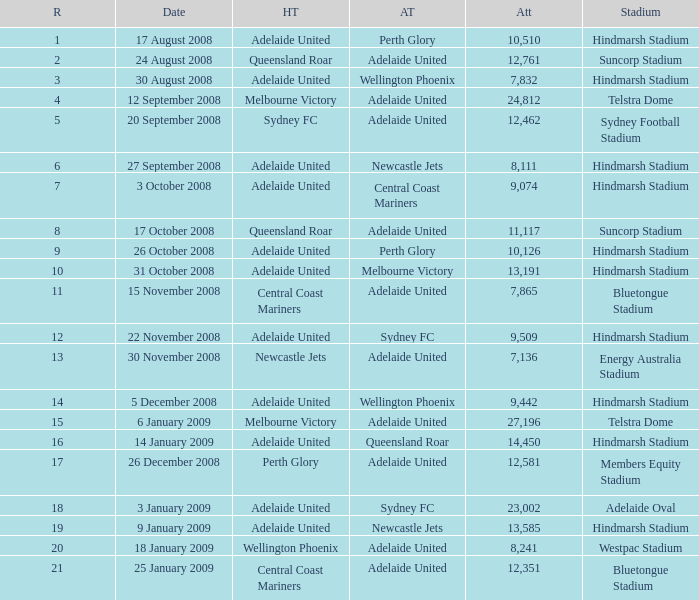Who was the away team when Queensland Roar was the home team in the round less than 3? Adelaide United. 